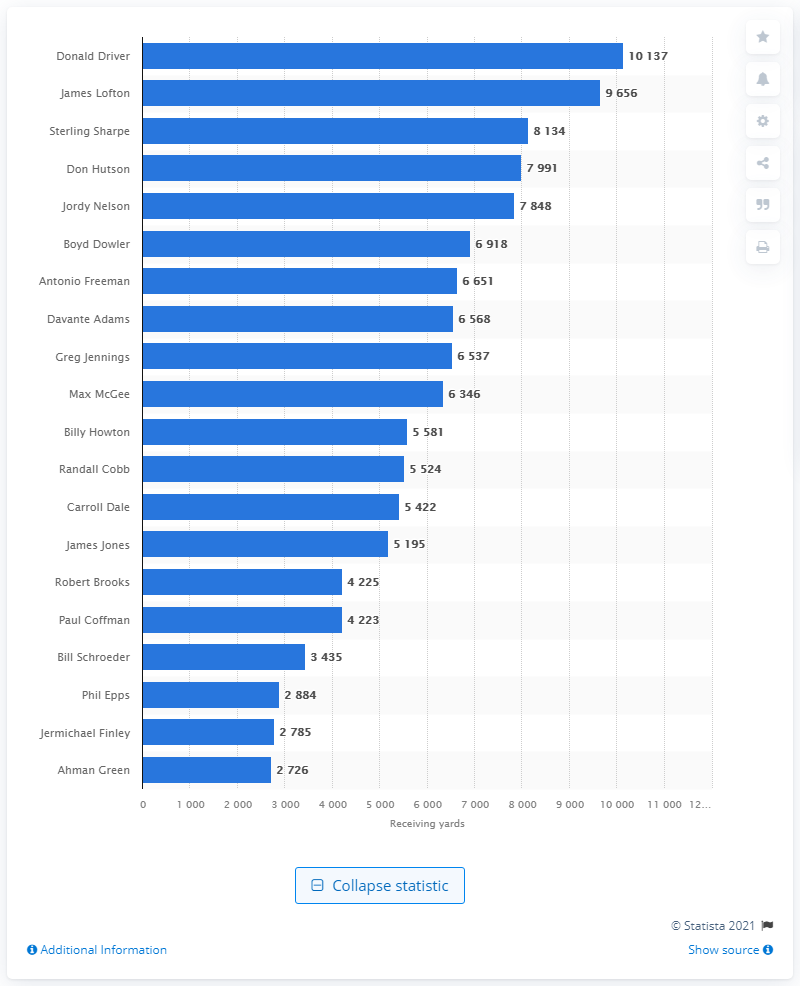Point out several critical features in this image. Donald Driver is the career receiving leader of the Green Bay Packers, with a total of... 